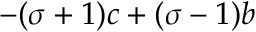<formula> <loc_0><loc_0><loc_500><loc_500>- ( \sigma + 1 ) c + ( \sigma - 1 ) b</formula> 